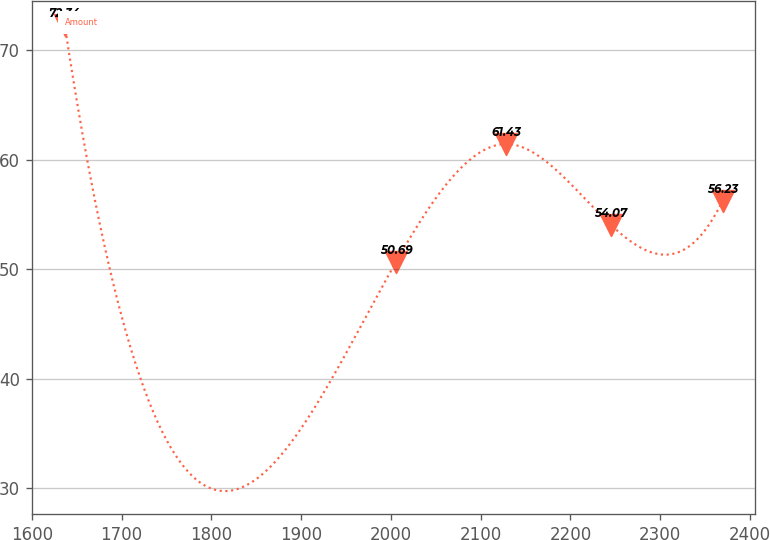<chart> <loc_0><loc_0><loc_500><loc_500><line_chart><ecel><fcel>Amount<nl><fcel>1636.52<fcel>72.34<nl><fcel>2005.89<fcel>50.69<nl><fcel>2128.13<fcel>61.43<nl><fcel>2244.63<fcel>54.07<nl><fcel>2369.44<fcel>56.23<nl></chart> 